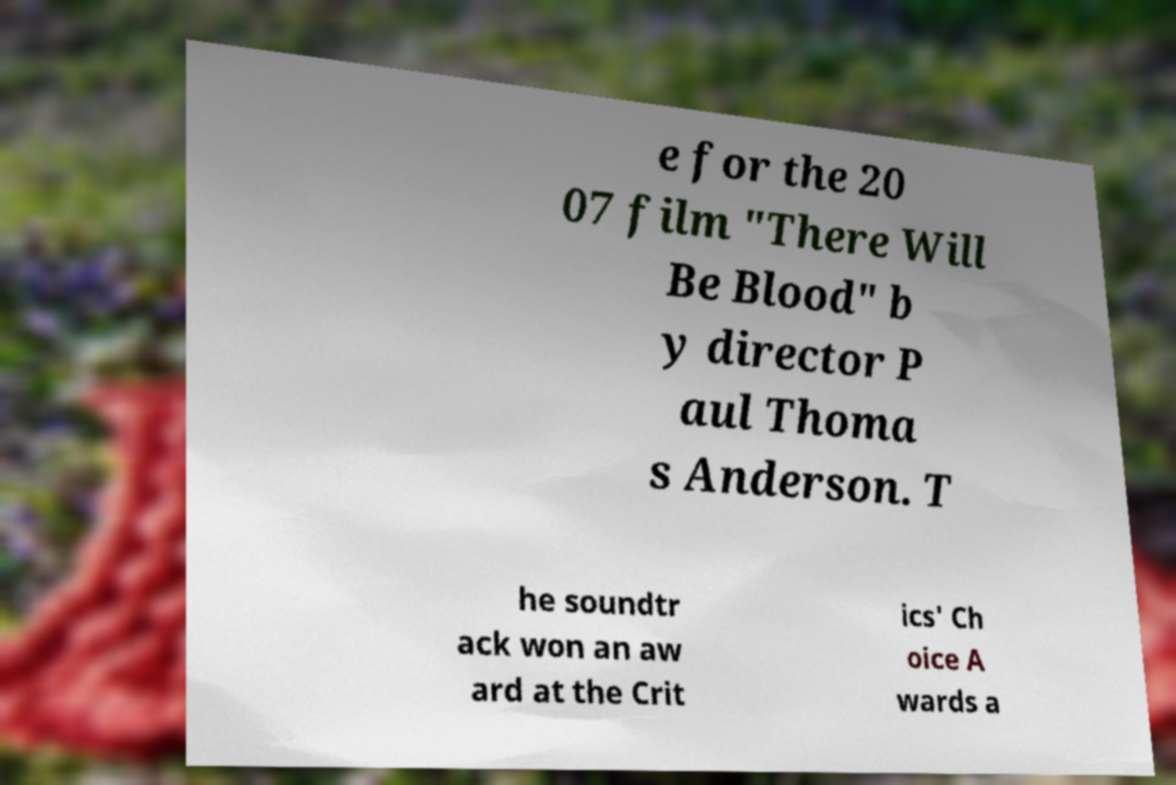I need the written content from this picture converted into text. Can you do that? e for the 20 07 film "There Will Be Blood" b y director P aul Thoma s Anderson. T he soundtr ack won an aw ard at the Crit ics' Ch oice A wards a 